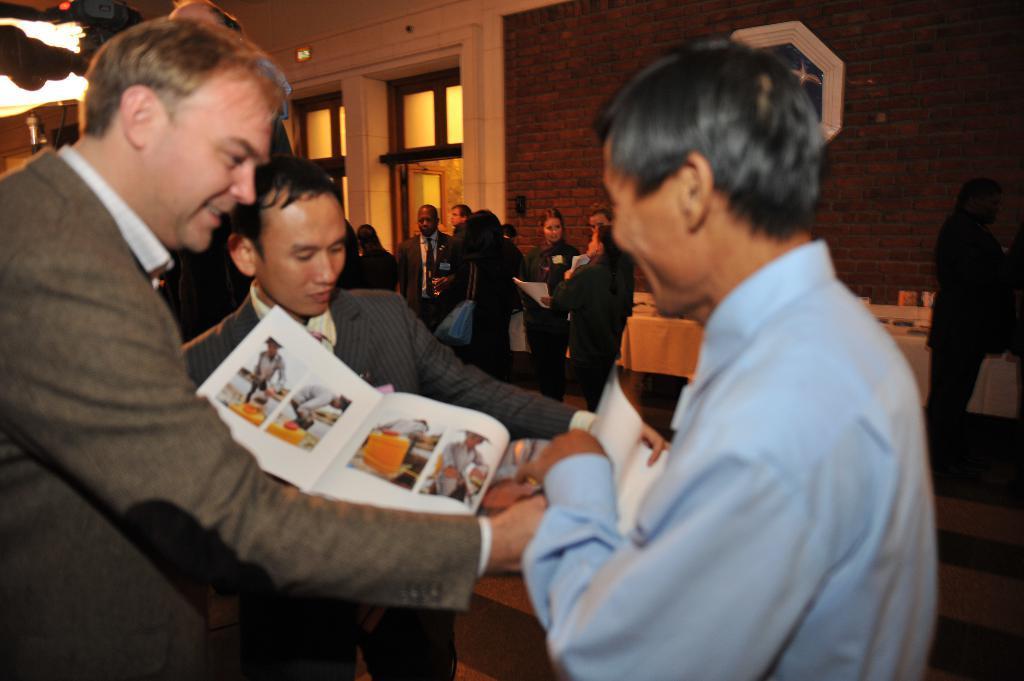Please provide a concise description of this image. In the picture we can see three men are standing and two men are wearing blazers and one man is wearing a shirt and they are holding some magazine with some images on it and behind them, we can see some people are standing near the tables and talking to each other and behind them we can see a wall with some doors to it, and to the ceiling we can see a light. 